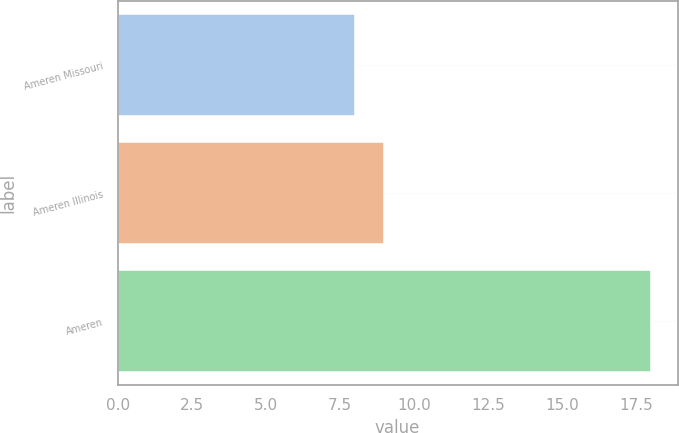Convert chart to OTSL. <chart><loc_0><loc_0><loc_500><loc_500><bar_chart><fcel>Ameren Missouri<fcel>Ameren Illinois<fcel>Ameren<nl><fcel>8<fcel>9<fcel>18<nl></chart> 